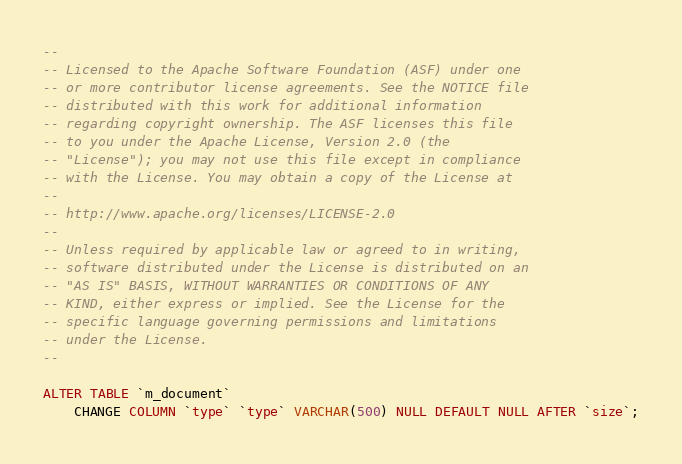Convert code to text. <code><loc_0><loc_0><loc_500><loc_500><_SQL_>--
-- Licensed to the Apache Software Foundation (ASF) under one
-- or more contributor license agreements. See the NOTICE file
-- distributed with this work for additional information
-- regarding copyright ownership. The ASF licenses this file
-- to you under the Apache License, Version 2.0 (the
-- "License"); you may not use this file except in compliance
-- with the License. You may obtain a copy of the License at
--
-- http://www.apache.org/licenses/LICENSE-2.0
--
-- Unless required by applicable law or agreed to in writing,
-- software distributed under the License is distributed on an
-- "AS IS" BASIS, WITHOUT WARRANTIES OR CONDITIONS OF ANY
-- KIND, either express or implied. See the License for the
-- specific language governing permissions and limitations
-- under the License.
--

ALTER TABLE `m_document`
	CHANGE COLUMN `type` `type` VARCHAR(500) NULL DEFAULT NULL AFTER `size`;</code> 